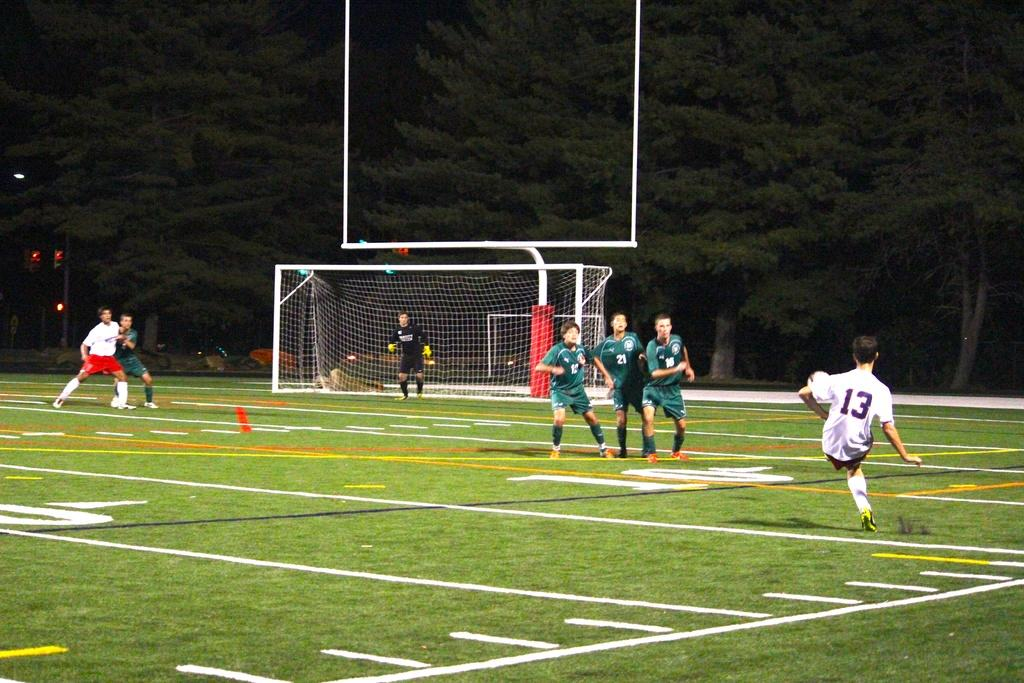Provide a one-sentence caption for the provided image. A soccer player number 13 about to deliver a kick. 